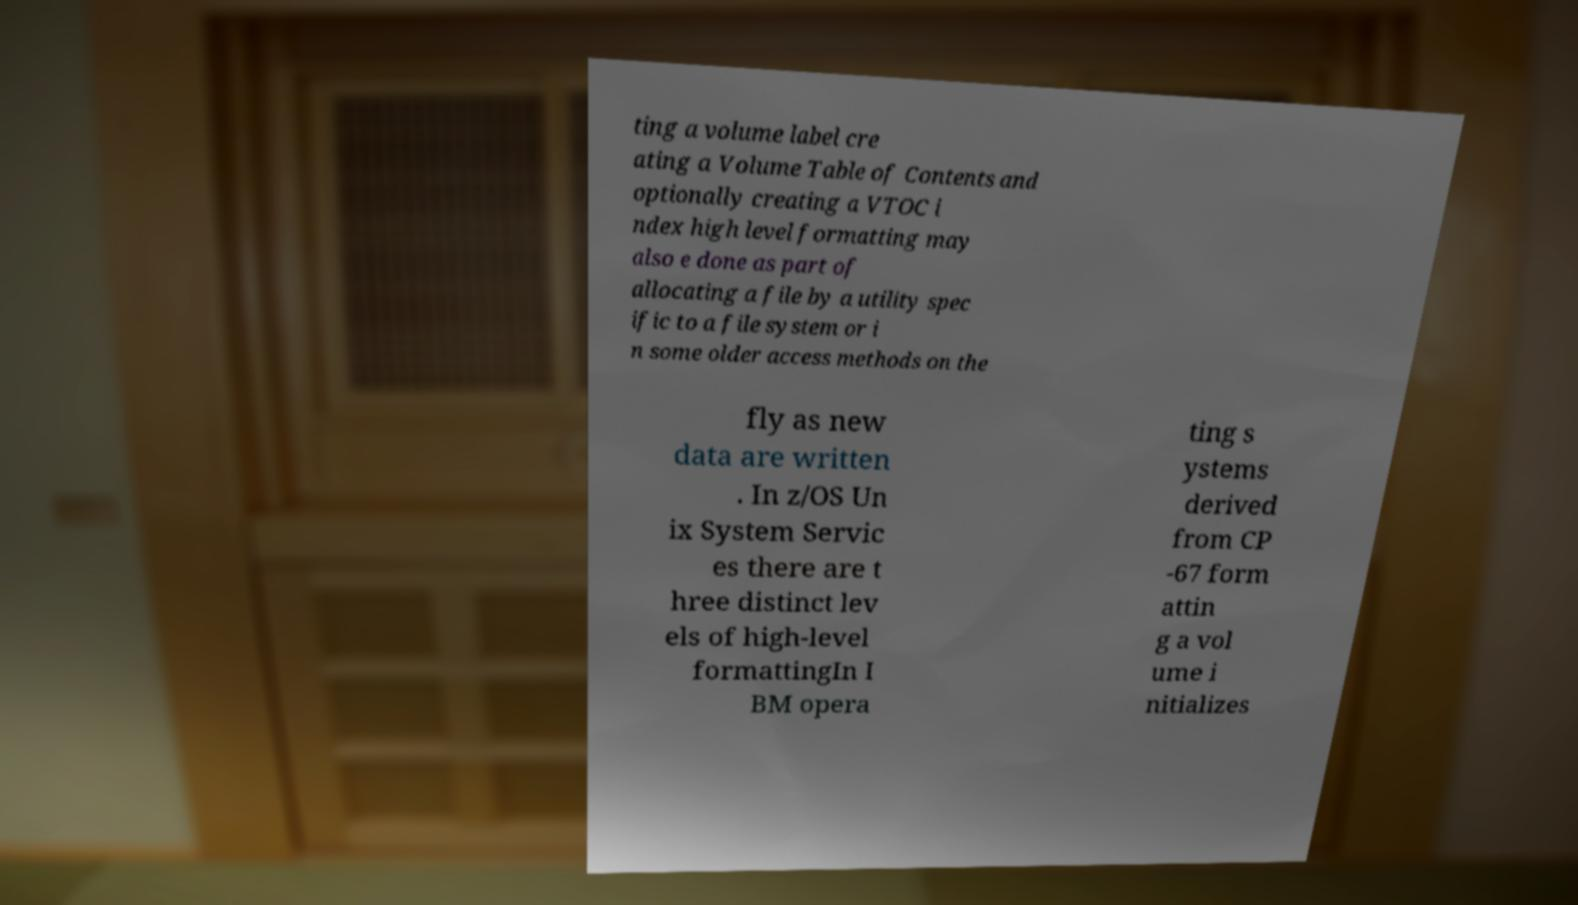Can you read and provide the text displayed in the image?This photo seems to have some interesting text. Can you extract and type it out for me? ting a volume label cre ating a Volume Table of Contents and optionally creating a VTOC i ndex high level formatting may also e done as part of allocating a file by a utility spec ific to a file system or i n some older access methods on the fly as new data are written . In z/OS Un ix System Servic es there are t hree distinct lev els of high-level formattingIn I BM opera ting s ystems derived from CP -67 form attin g a vol ume i nitializes 